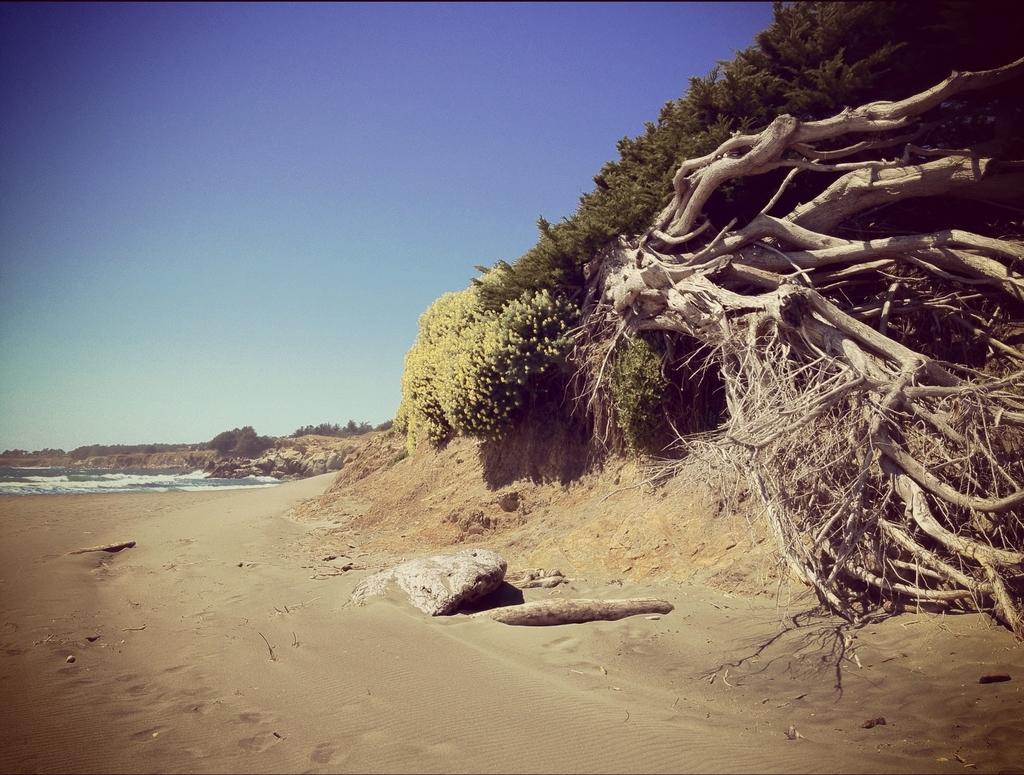How would you summarize this image in a sentence or two? In this picture we can see water, and sand in the background we can see trees, sky. 